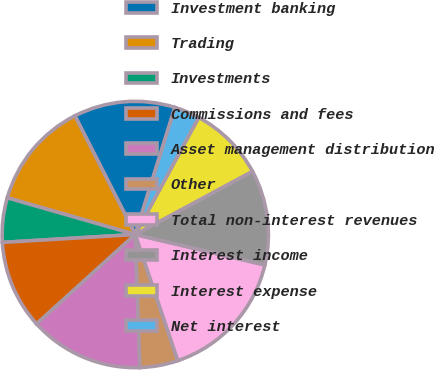Convert chart to OTSL. <chart><loc_0><loc_0><loc_500><loc_500><pie_chart><fcel>Investment banking<fcel>Trading<fcel>Investments<fcel>Commissions and fees<fcel>Asset management distribution<fcel>Other<fcel>Total non-interest revenues<fcel>Interest income<fcel>Interest expense<fcel>Net interest<nl><fcel>12.31%<fcel>13.07%<fcel>5.39%<fcel>10.77%<fcel>13.84%<fcel>4.62%<fcel>16.15%<fcel>11.54%<fcel>9.23%<fcel>3.08%<nl></chart> 